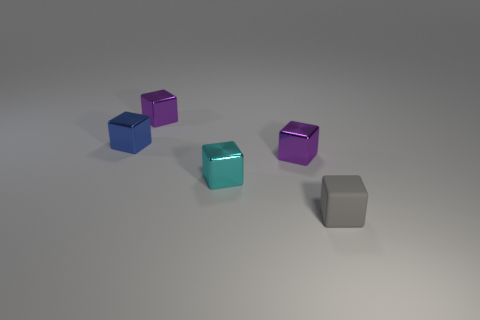What is the size of the blue metallic thing that is the same shape as the gray rubber object?
Keep it short and to the point. Small. Is there any other thing that is the same size as the gray matte object?
Keep it short and to the point. Yes. Are there fewer blue metal blocks that are right of the small gray rubber cube than tiny cubes?
Make the answer very short. Yes. Does the blue object have the same shape as the small cyan object?
Provide a succinct answer. Yes. What is the color of the other rubber thing that is the same shape as the cyan thing?
Provide a short and direct response. Gray. What number of shiny things are the same color as the rubber thing?
Keep it short and to the point. 0. How many things are small things that are in front of the small cyan metallic cube or tiny gray metallic objects?
Provide a short and direct response. 1. What size is the gray thing on the right side of the tiny cyan object?
Ensure brevity in your answer.  Small. Are there fewer small objects than gray matte cubes?
Make the answer very short. No. Are the small purple cube on the left side of the cyan block and the purple thing on the right side of the tiny cyan cube made of the same material?
Your answer should be very brief. Yes. 